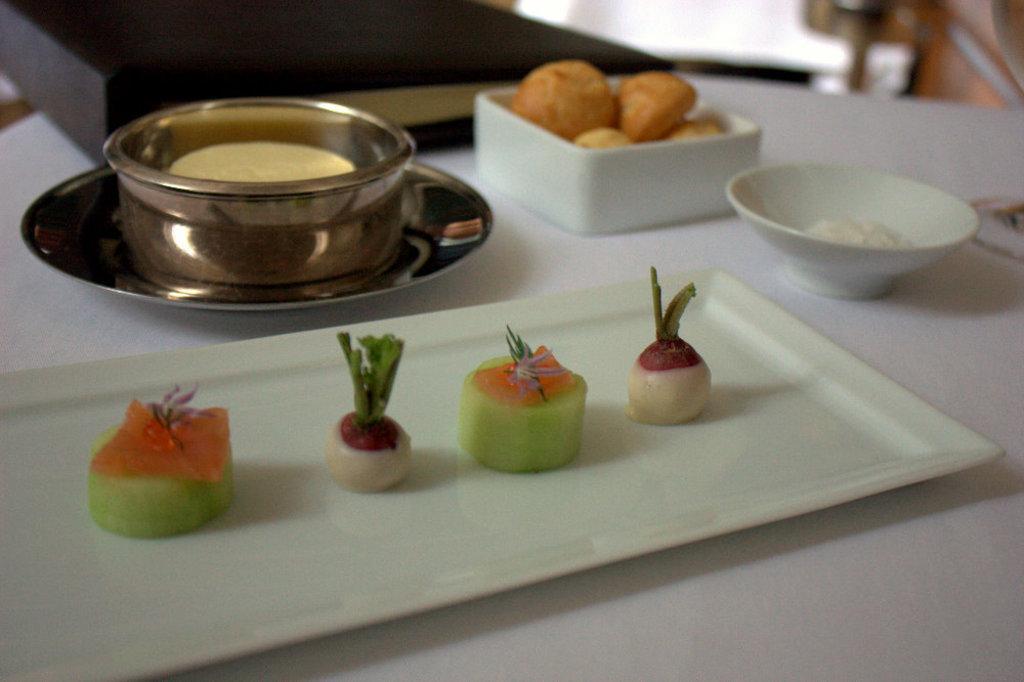In one or two sentences, can you explain what this image depicts? In the picture I can see food items on white color tray and bowls. I can also see a saucer and some other objects on a white color table. The background of the image is blurred. 